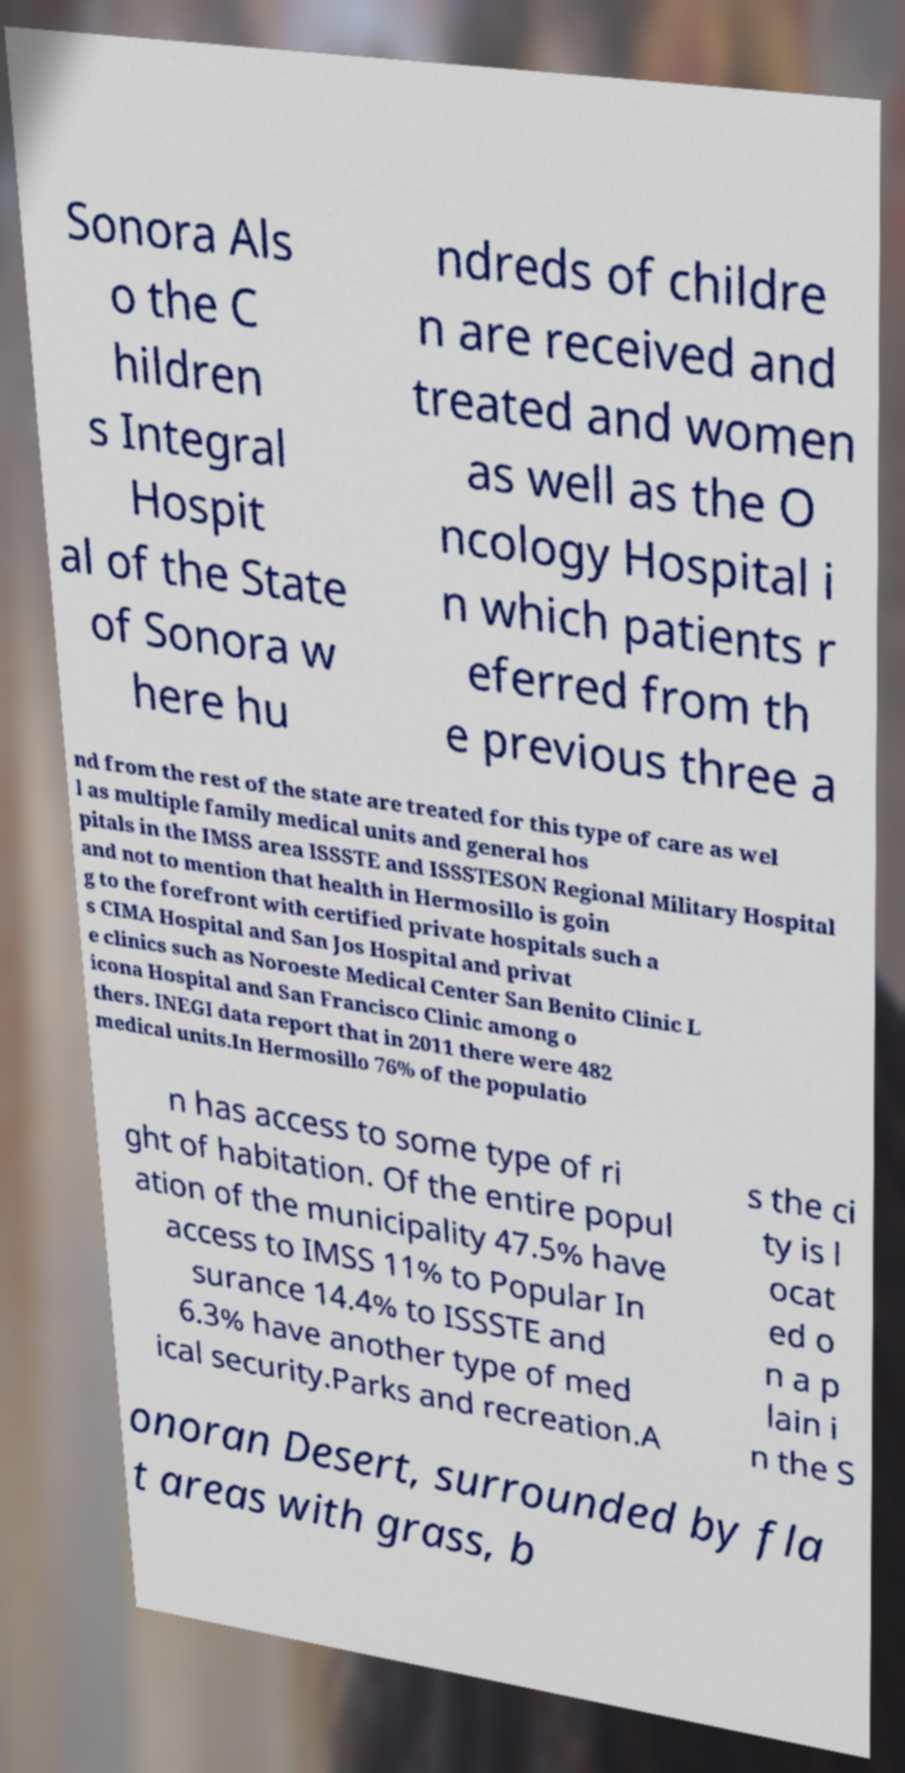Can you accurately transcribe the text from the provided image for me? Sonora Als o the C hildren s Integral Hospit al of the State of Sonora w here hu ndreds of childre n are received and treated and women as well as the O ncology Hospital i n which patients r eferred from th e previous three a nd from the rest of the state are treated for this type of care as wel l as multiple family medical units and general hos pitals in the IMSS area ISSSTE and ISSSTESON Regional Military Hospital and not to mention that health in Hermosillo is goin g to the forefront with certified private hospitals such a s CIMA Hospital and San Jos Hospital and privat e clinics such as Noroeste Medical Center San Benito Clinic L icona Hospital and San Francisco Clinic among o thers. INEGI data report that in 2011 there were 482 medical units.In Hermosillo 76% of the populatio n has access to some type of ri ght of habitation. Of the entire popul ation of the municipality 47.5% have access to IMSS 11% to Popular In surance 14.4% to ISSSTE and 6.3% have another type of med ical security.Parks and recreation.A s the ci ty is l ocat ed o n a p lain i n the S onoran Desert, surrounded by fla t areas with grass, b 